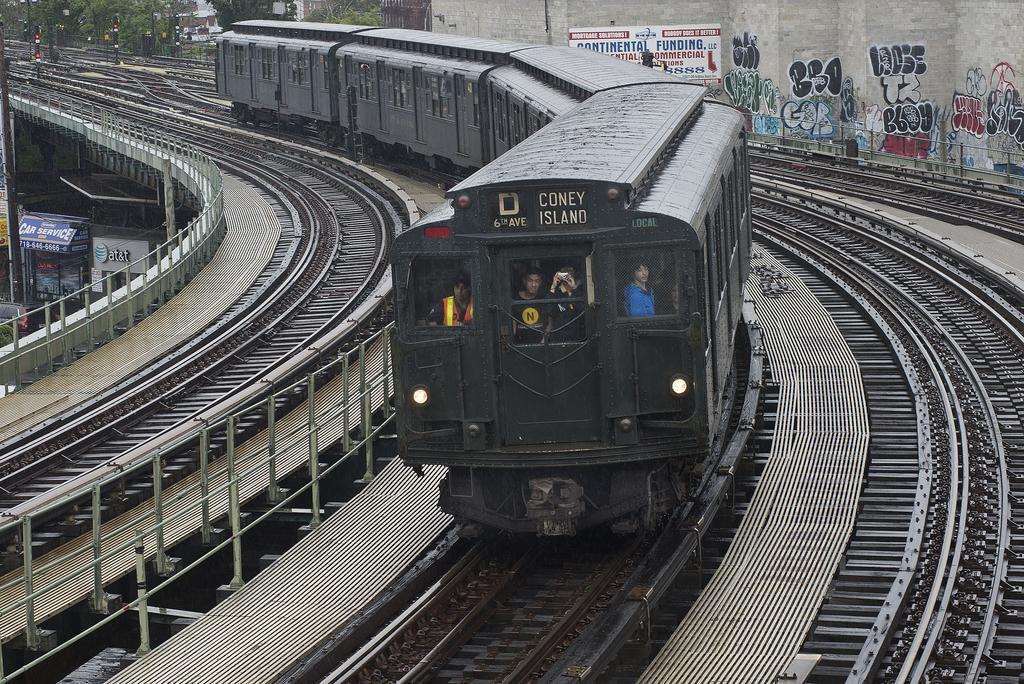<image>
Create a compact narrative representing the image presented. the word coney is on the front of a train 